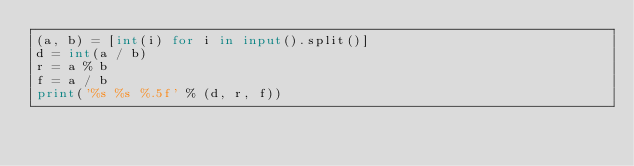Convert code to text. <code><loc_0><loc_0><loc_500><loc_500><_Python_>(a, b) = [int(i) for i in input().split()]
d = int(a / b)
r = a % b
f = a / b
print('%s %s %.5f' % (d, r, f))</code> 